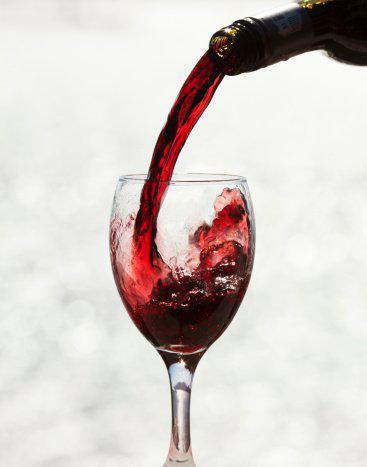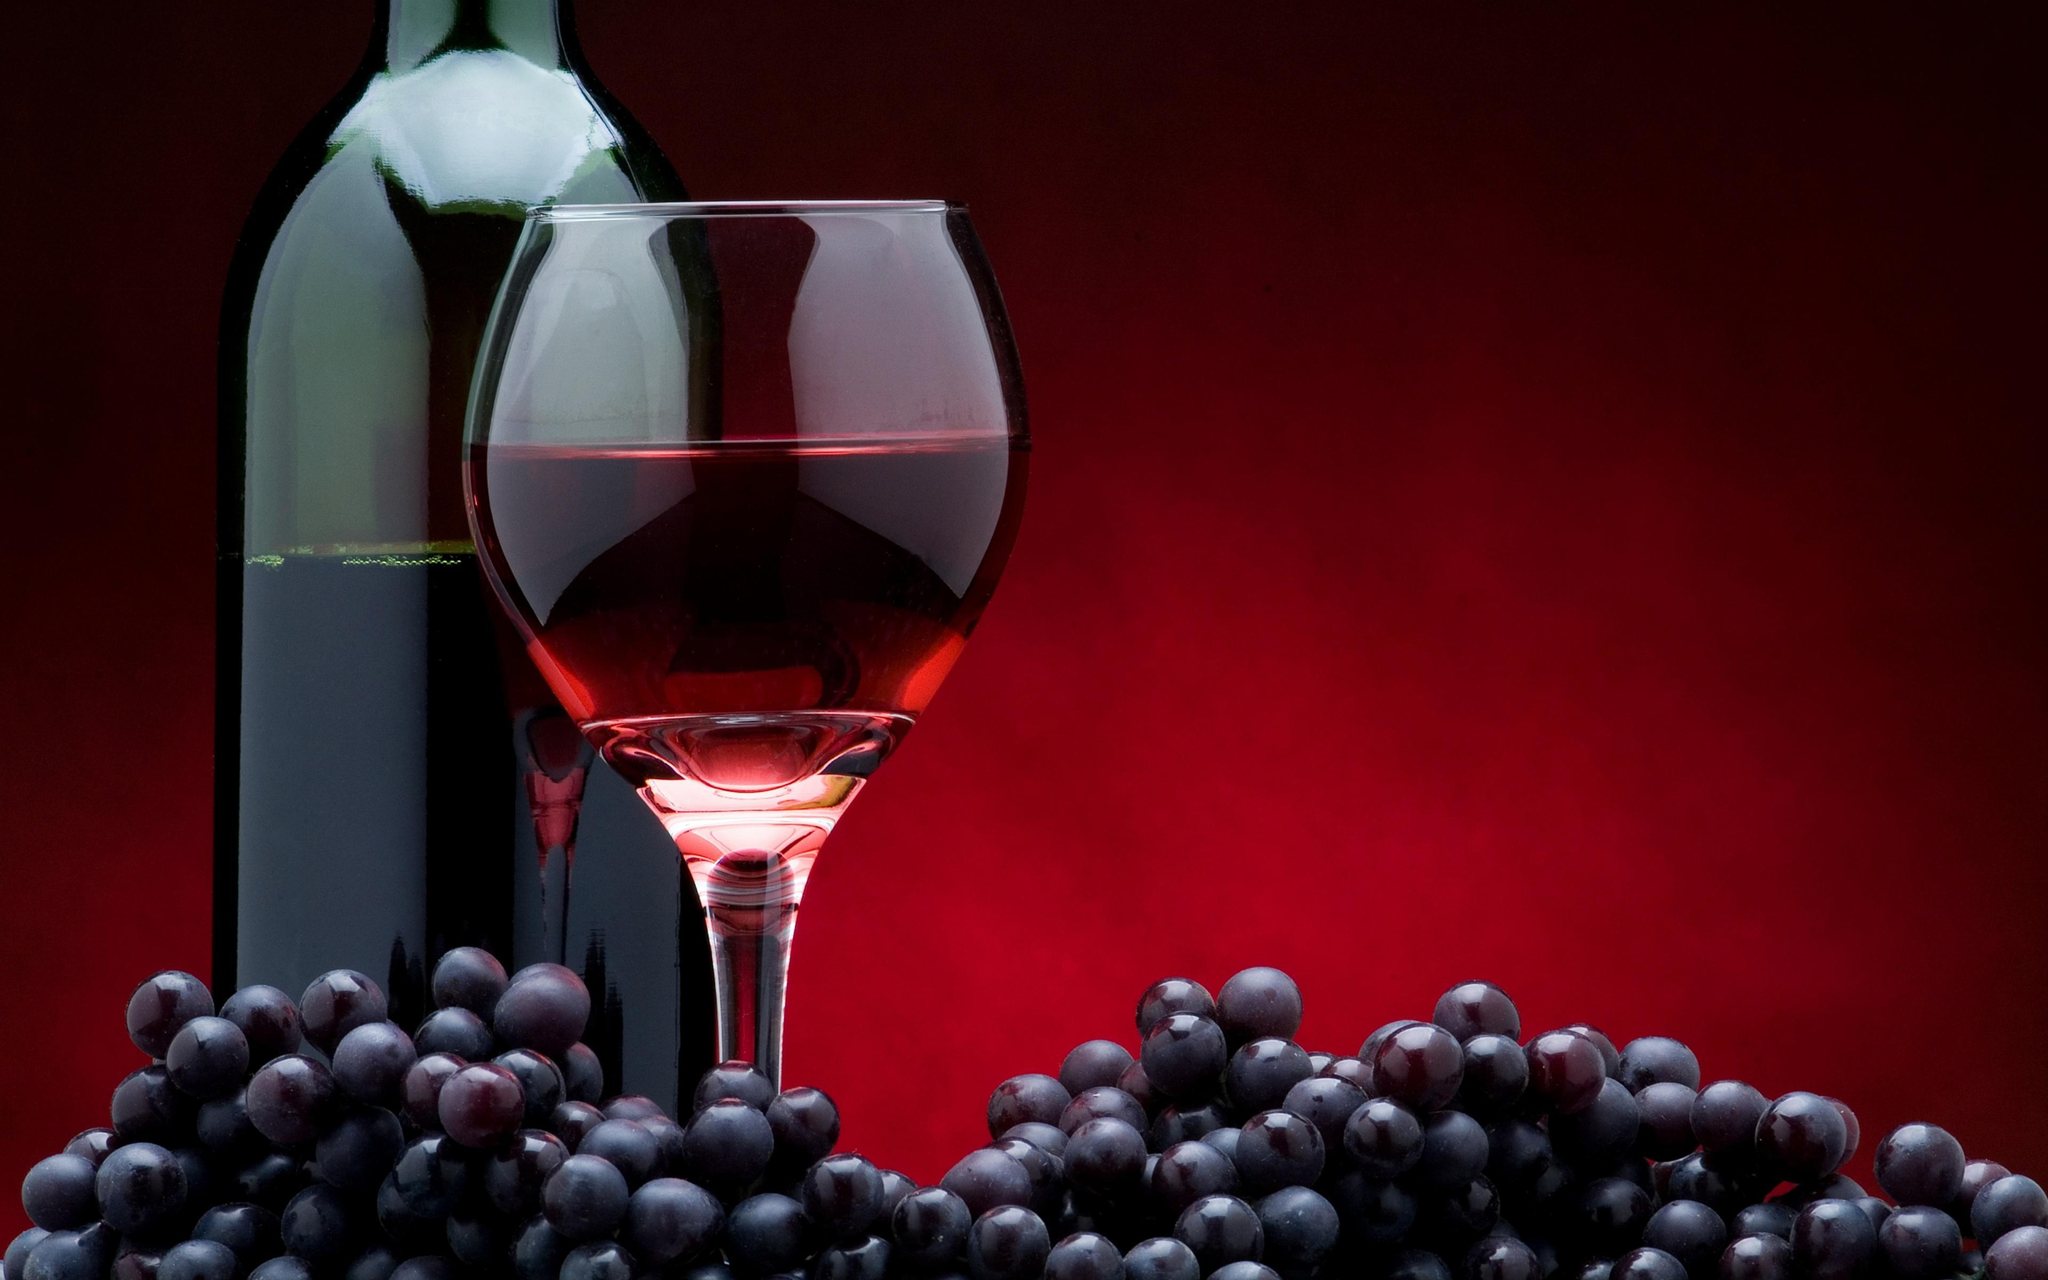The first image is the image on the left, the second image is the image on the right. Given the left and right images, does the statement "Wine is pouring from a bottle into a glass in the left image." hold true? Answer yes or no. Yes. The first image is the image on the left, the second image is the image on the right. Assess this claim about the two images: "In one of the images, red wine is being poured into a wine glass". Correct or not? Answer yes or no. Yes. 